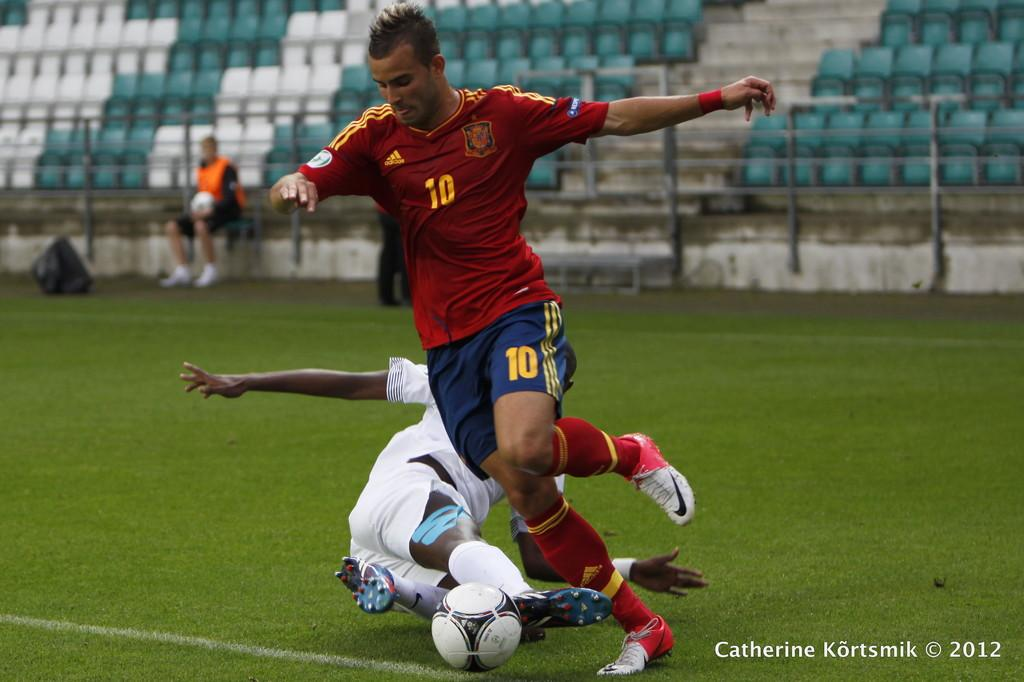<image>
Describe the image concisely. A soccer player with the number 10 on his shorts is kicking the ball. 